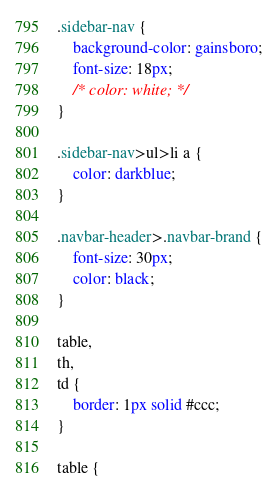<code> <loc_0><loc_0><loc_500><loc_500><_CSS_>.sidebar-nav {
    background-color: gainsboro;
    font-size: 18px;
    /* color: white; */
}

.sidebar-nav>ul>li a {
    color: darkblue;
}

.navbar-header>.navbar-brand {
    font-size: 30px;
    color: black;
}

table,
th,
td {
    border: 1px solid #ccc;
}

table {</code> 